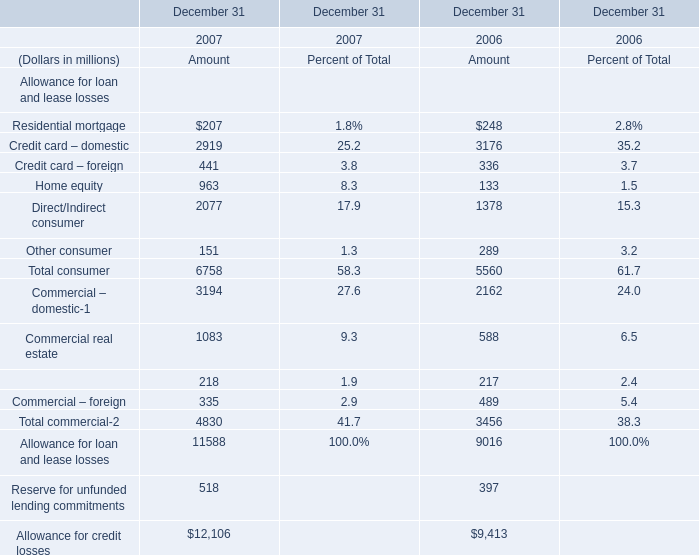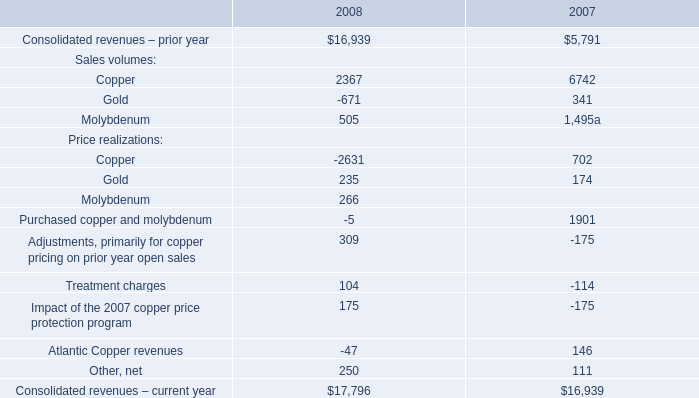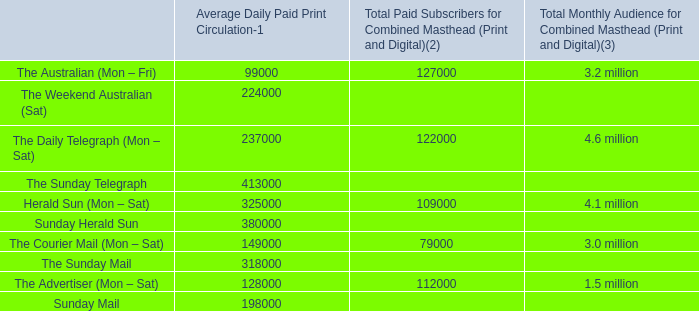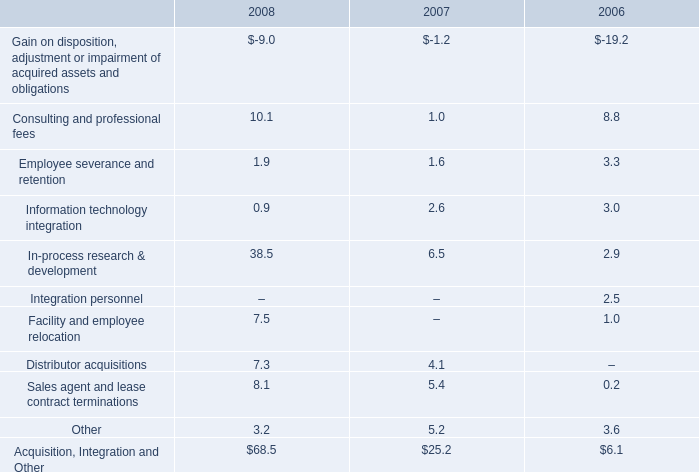What is the sum of Commercial – domestic of December 31 2006 Amount, Sunday Mail of Average Daily Paid Print Circulation, and Consolidated revenues – prior year of 2008 ? 
Computations: ((2162.0 + 198000.0) + 16939.0)
Answer: 217101.0. 